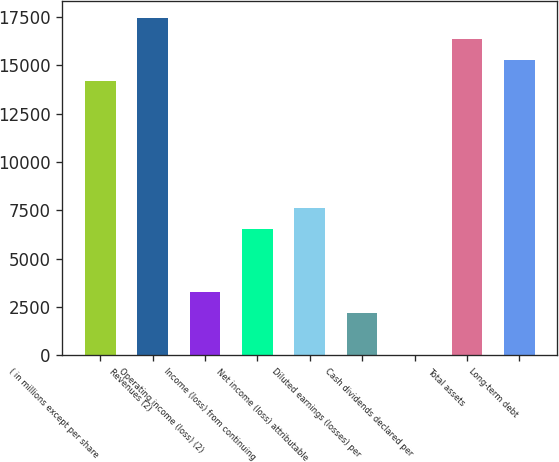<chart> <loc_0><loc_0><loc_500><loc_500><bar_chart><fcel>( in millions except per share<fcel>Revenues (2)<fcel>Operating income (loss) (2)<fcel>Income (loss) from continuing<fcel>Net income (loss) attributable<fcel>Diluted earnings (losses) per<fcel>Cash dividends declared per<fcel>Total assets<fcel>Long-term debt<nl><fcel>14180.4<fcel>17452.7<fcel>3272.46<fcel>6544.83<fcel>7635.62<fcel>2181.67<fcel>0.09<fcel>16361.9<fcel>15271.1<nl></chart> 